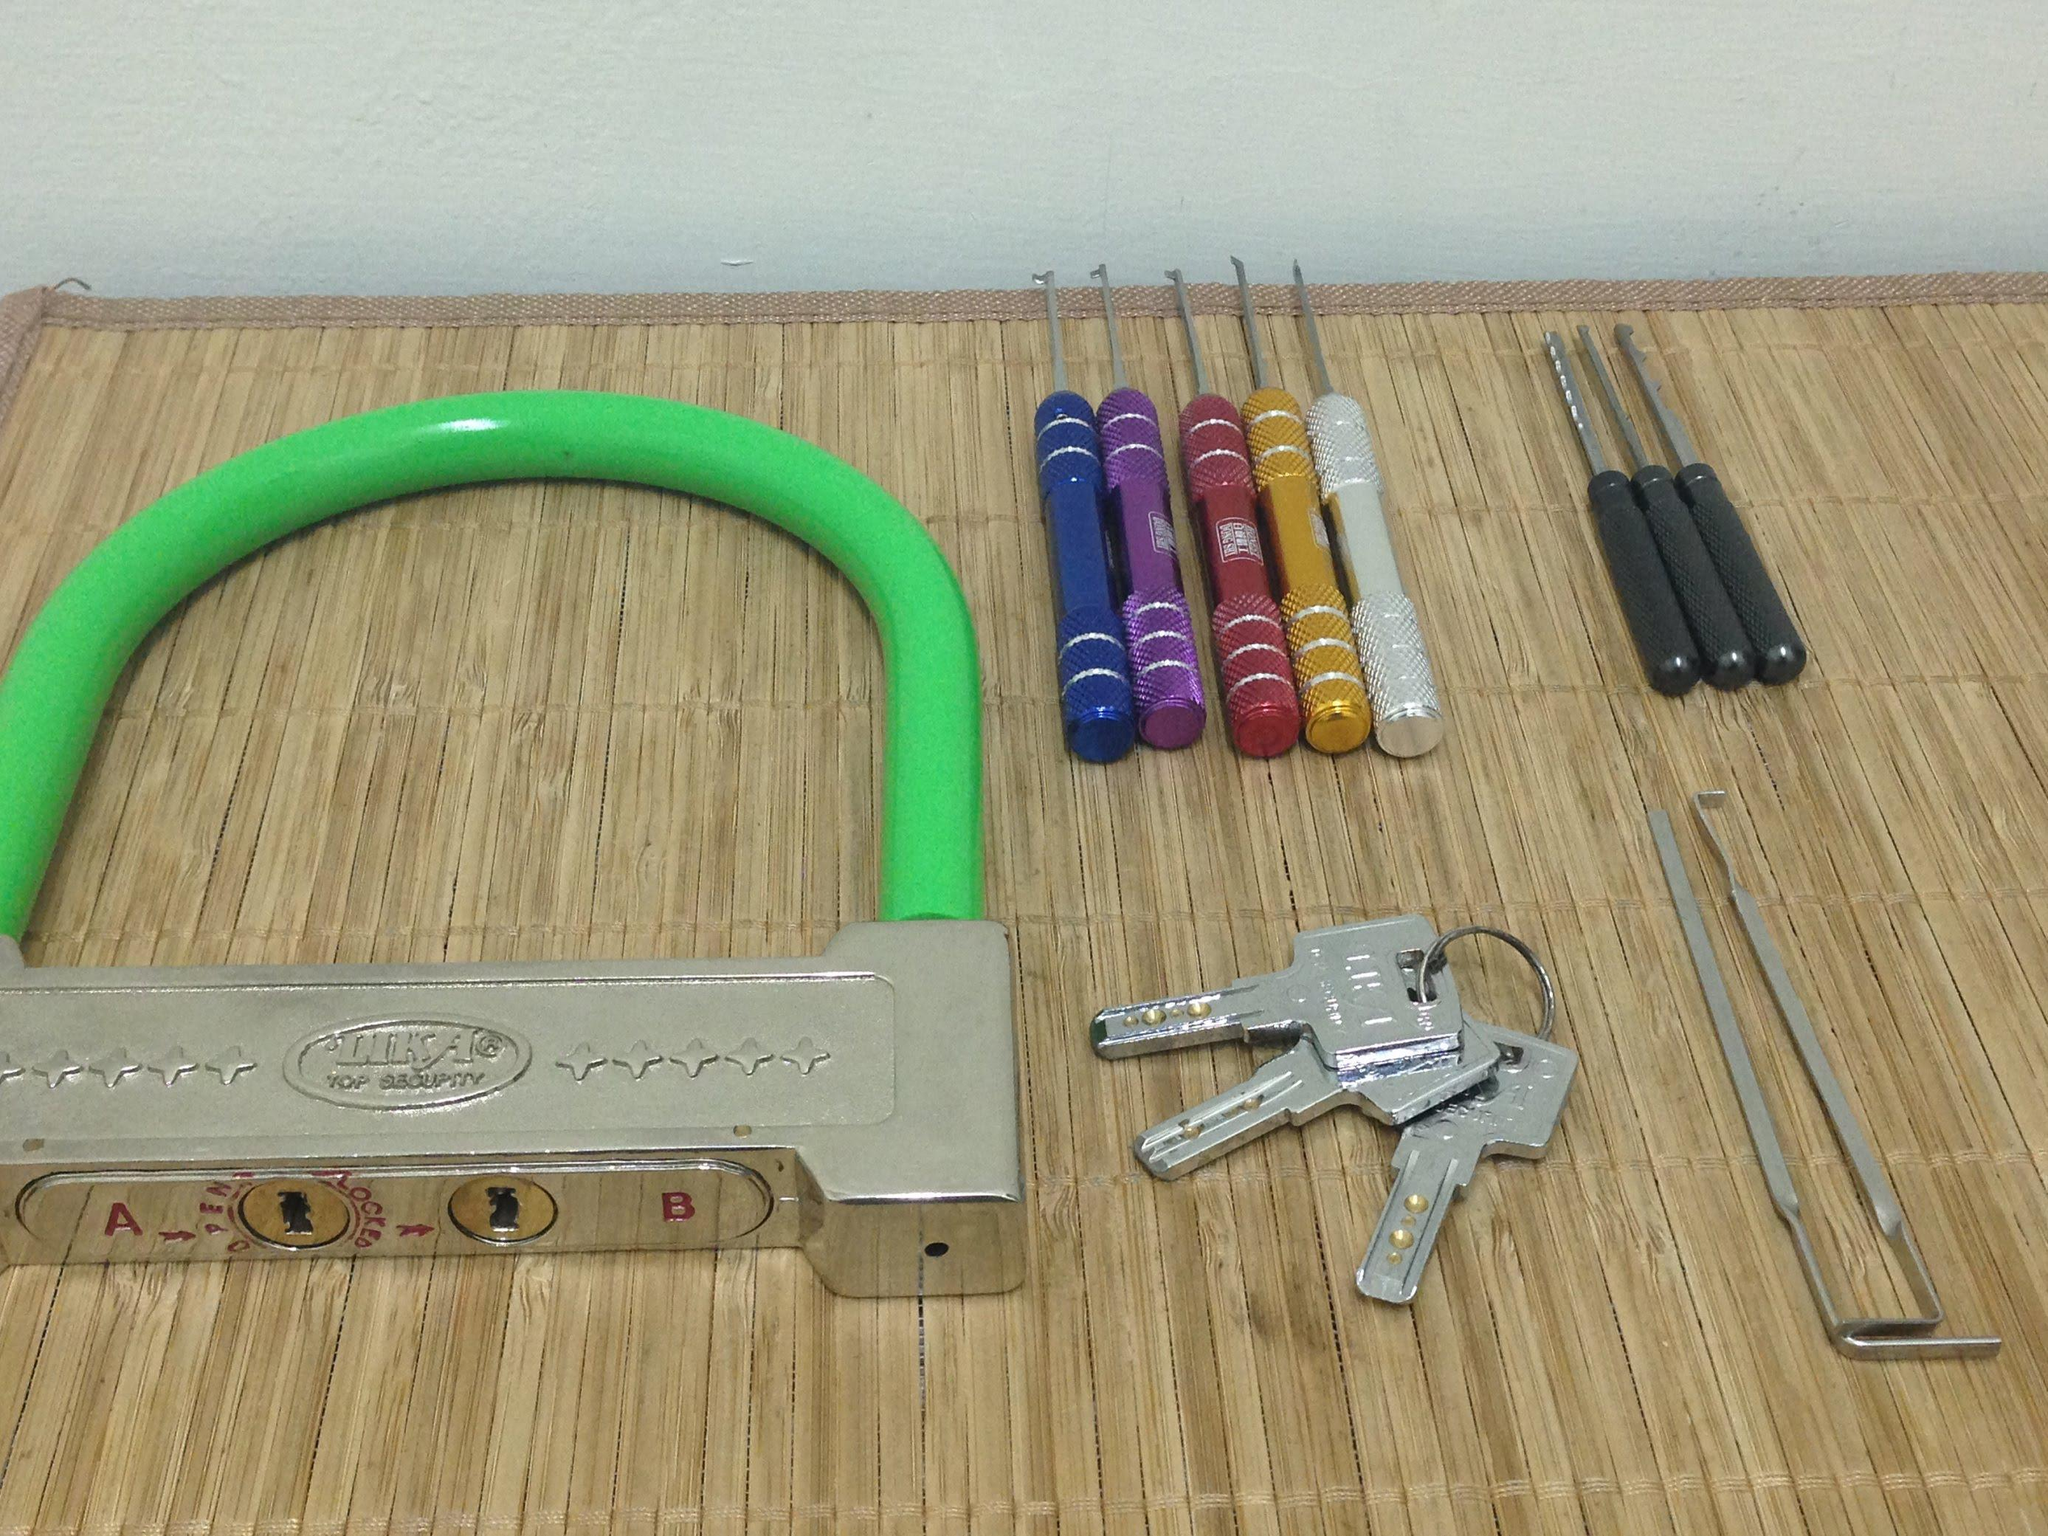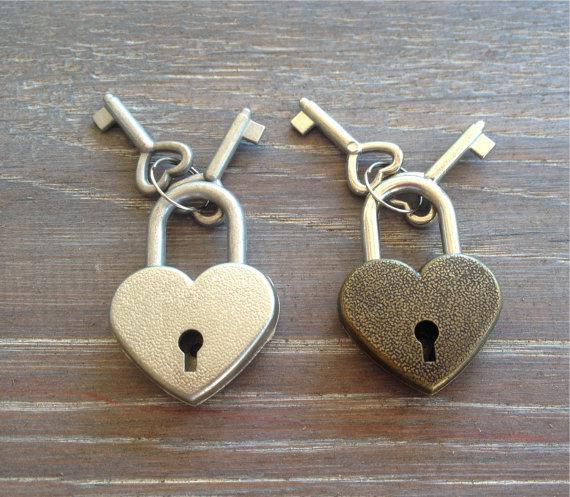The first image is the image on the left, the second image is the image on the right. Considering the images on both sides, is "An image shows one lock with two keys inserted into it." valid? Answer yes or no. No. 